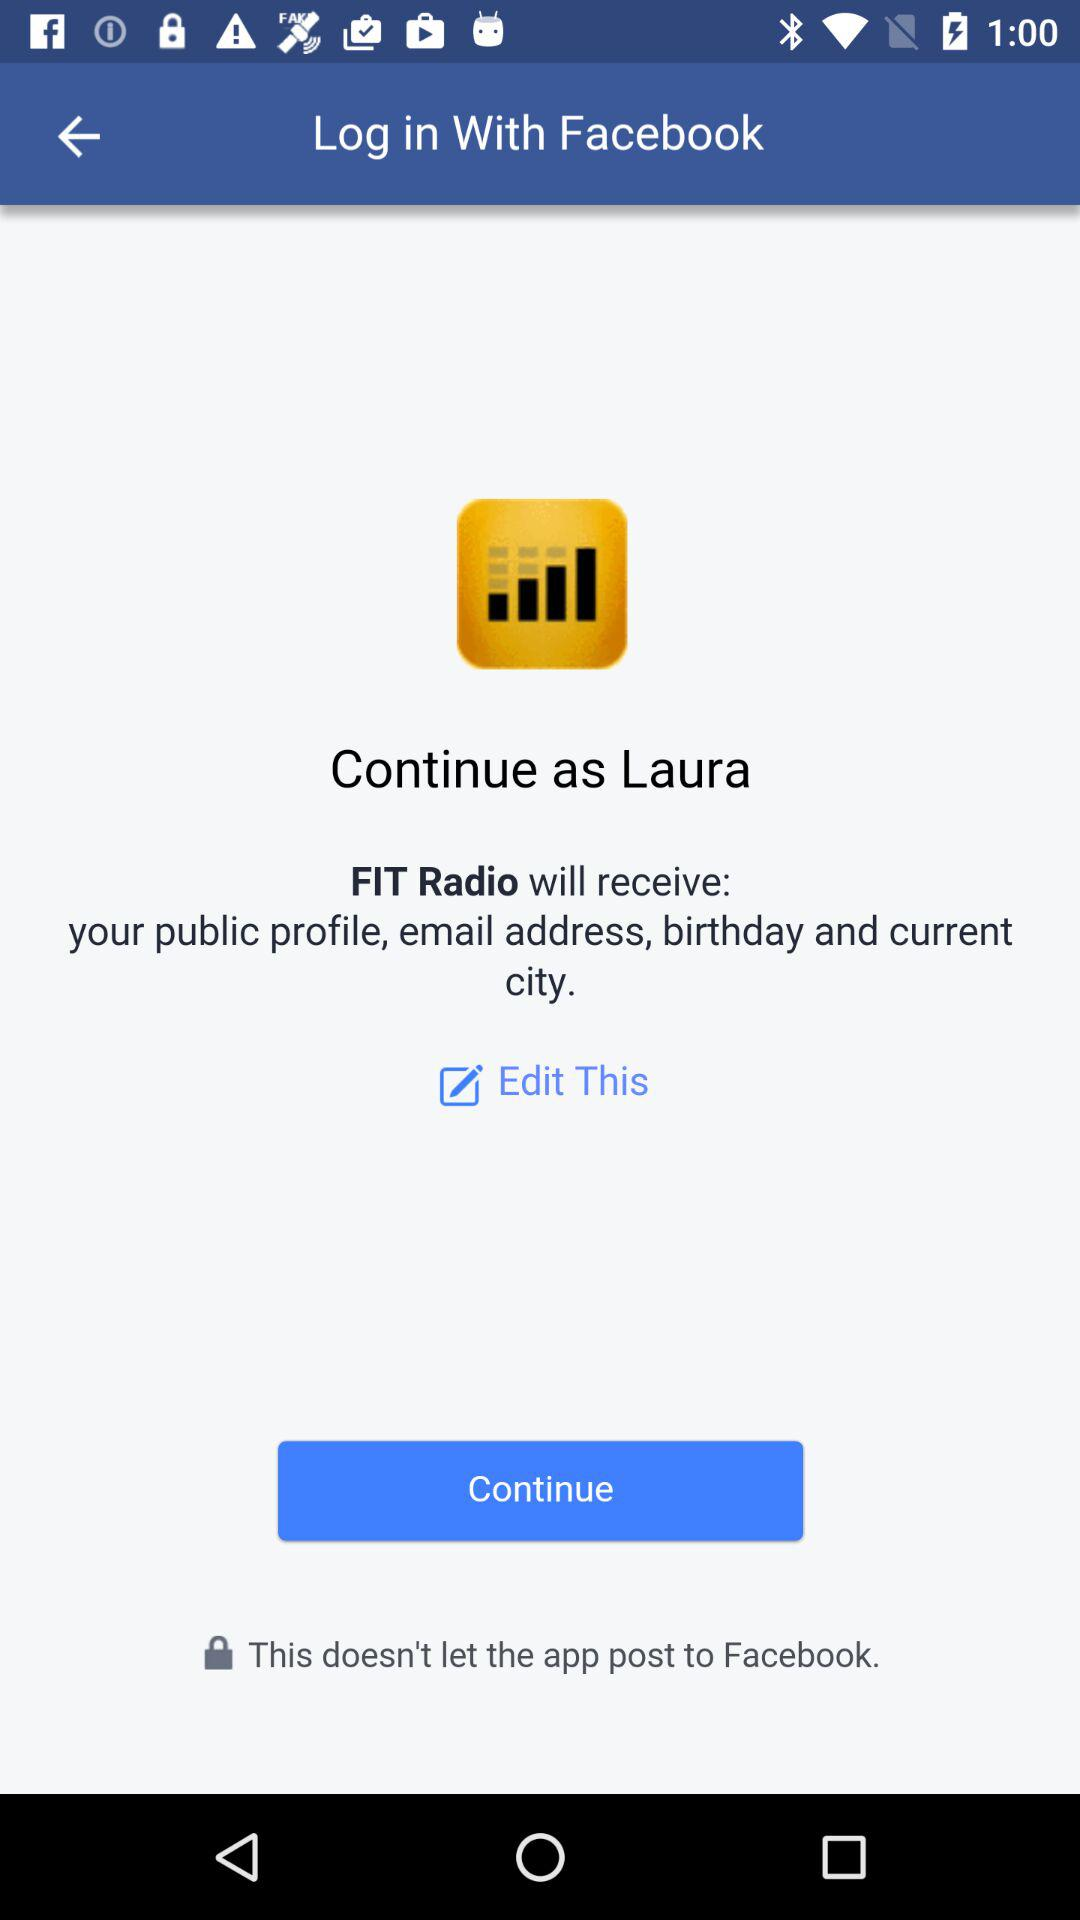What is the user name? The user name is Laura. 